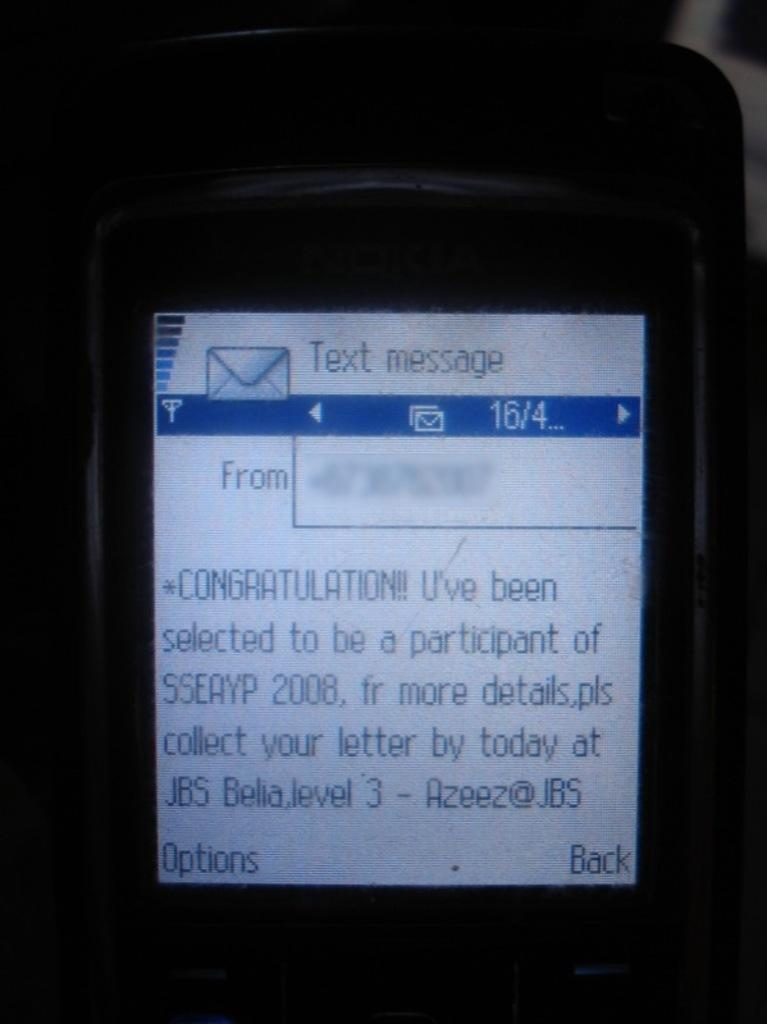<image>
Relay a brief, clear account of the picture shown. A congratulations text is displayed on a Nokia cell phone. 